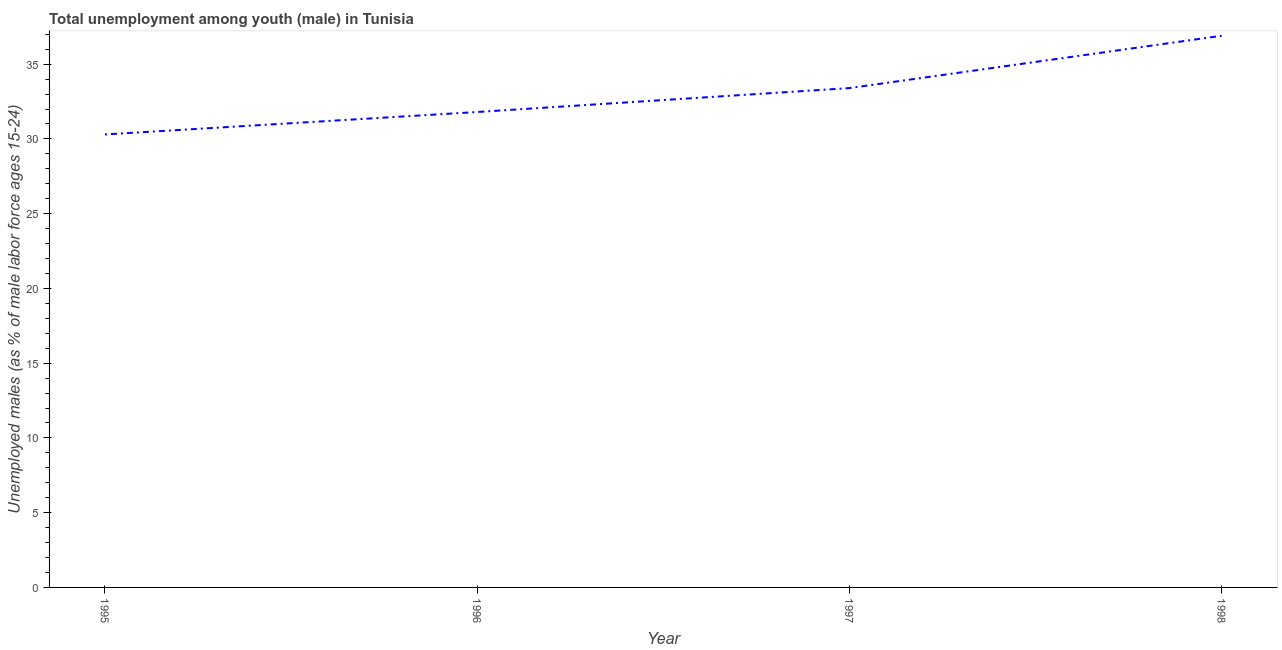What is the unemployed male youth population in 1995?
Your answer should be very brief. 30.3. Across all years, what is the maximum unemployed male youth population?
Provide a short and direct response. 36.9. Across all years, what is the minimum unemployed male youth population?
Provide a short and direct response. 30.3. In which year was the unemployed male youth population maximum?
Offer a very short reply. 1998. What is the sum of the unemployed male youth population?
Your answer should be very brief. 132.4. What is the average unemployed male youth population per year?
Keep it short and to the point. 33.1. What is the median unemployed male youth population?
Make the answer very short. 32.6. In how many years, is the unemployed male youth population greater than 22 %?
Keep it short and to the point. 4. Do a majority of the years between 1998 and 1997 (inclusive) have unemployed male youth population greater than 27 %?
Keep it short and to the point. No. What is the ratio of the unemployed male youth population in 1995 to that in 1997?
Give a very brief answer. 0.91. Is the unemployed male youth population in 1996 less than that in 1997?
Your answer should be very brief. Yes. What is the difference between the highest and the lowest unemployed male youth population?
Provide a short and direct response. 6.6. In how many years, is the unemployed male youth population greater than the average unemployed male youth population taken over all years?
Provide a short and direct response. 2. How many lines are there?
Your response must be concise. 1. How many years are there in the graph?
Your response must be concise. 4. What is the difference between two consecutive major ticks on the Y-axis?
Make the answer very short. 5. Does the graph contain any zero values?
Your response must be concise. No. What is the title of the graph?
Give a very brief answer. Total unemployment among youth (male) in Tunisia. What is the label or title of the X-axis?
Your answer should be compact. Year. What is the label or title of the Y-axis?
Offer a very short reply. Unemployed males (as % of male labor force ages 15-24). What is the Unemployed males (as % of male labor force ages 15-24) of 1995?
Your answer should be compact. 30.3. What is the Unemployed males (as % of male labor force ages 15-24) of 1996?
Give a very brief answer. 31.8. What is the Unemployed males (as % of male labor force ages 15-24) in 1997?
Offer a very short reply. 33.4. What is the Unemployed males (as % of male labor force ages 15-24) of 1998?
Make the answer very short. 36.9. What is the difference between the Unemployed males (as % of male labor force ages 15-24) in 1996 and 1997?
Your answer should be compact. -1.6. What is the difference between the Unemployed males (as % of male labor force ages 15-24) in 1997 and 1998?
Your answer should be very brief. -3.5. What is the ratio of the Unemployed males (as % of male labor force ages 15-24) in 1995 to that in 1996?
Provide a succinct answer. 0.95. What is the ratio of the Unemployed males (as % of male labor force ages 15-24) in 1995 to that in 1997?
Give a very brief answer. 0.91. What is the ratio of the Unemployed males (as % of male labor force ages 15-24) in 1995 to that in 1998?
Offer a very short reply. 0.82. What is the ratio of the Unemployed males (as % of male labor force ages 15-24) in 1996 to that in 1997?
Your answer should be compact. 0.95. What is the ratio of the Unemployed males (as % of male labor force ages 15-24) in 1996 to that in 1998?
Your answer should be very brief. 0.86. What is the ratio of the Unemployed males (as % of male labor force ages 15-24) in 1997 to that in 1998?
Give a very brief answer. 0.91. 